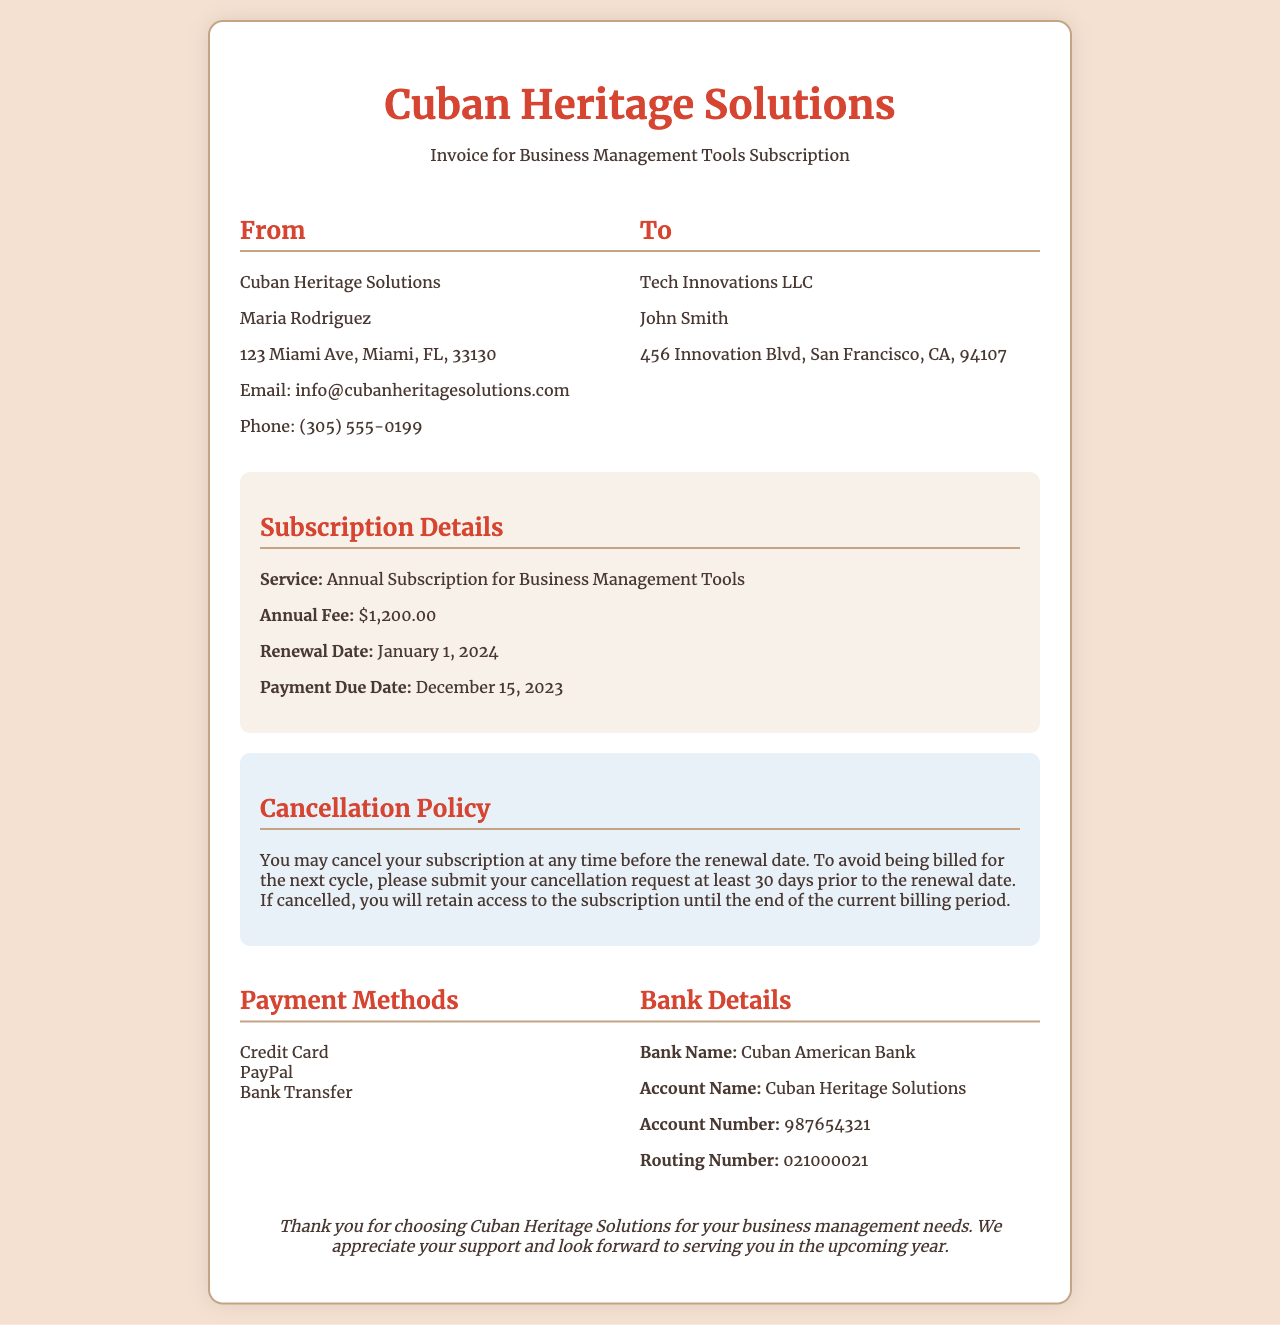what is the service provided? The invoice specifies that the service provided is "Annual Subscription for Business Management Tools."
Answer: Annual Subscription for Business Management Tools what is the annual fee? The annual fee listed on the invoice is $1,200.00.
Answer: $1,200.00 when is the payment due date? The document specifies that the payment due date is December 15, 2023.
Answer: December 15, 2023 what is the cancellation notice period? The cancellation policy states that a cancellation request must be submitted at least 30 days prior to the renewal date.
Answer: 30 days who is the client? The document indicates that the client is "Tech Innovations LLC."
Answer: Tech Innovations LLC when is the renewal date? The renewal date for the subscription is indicated as January 1, 2024.
Answer: January 1, 2024 what are the payment methods accepted? The invoice lists several payment methods, including Credit Card, PayPal, and Bank Transfer.
Answer: Credit Card, PayPal, Bank Transfer what happens if I cancel the subscription? According to the cancellation policy, if cancelled, you will retain access to the subscription until the end of the current billing period.
Answer: Retain access until the end of the current billing period 